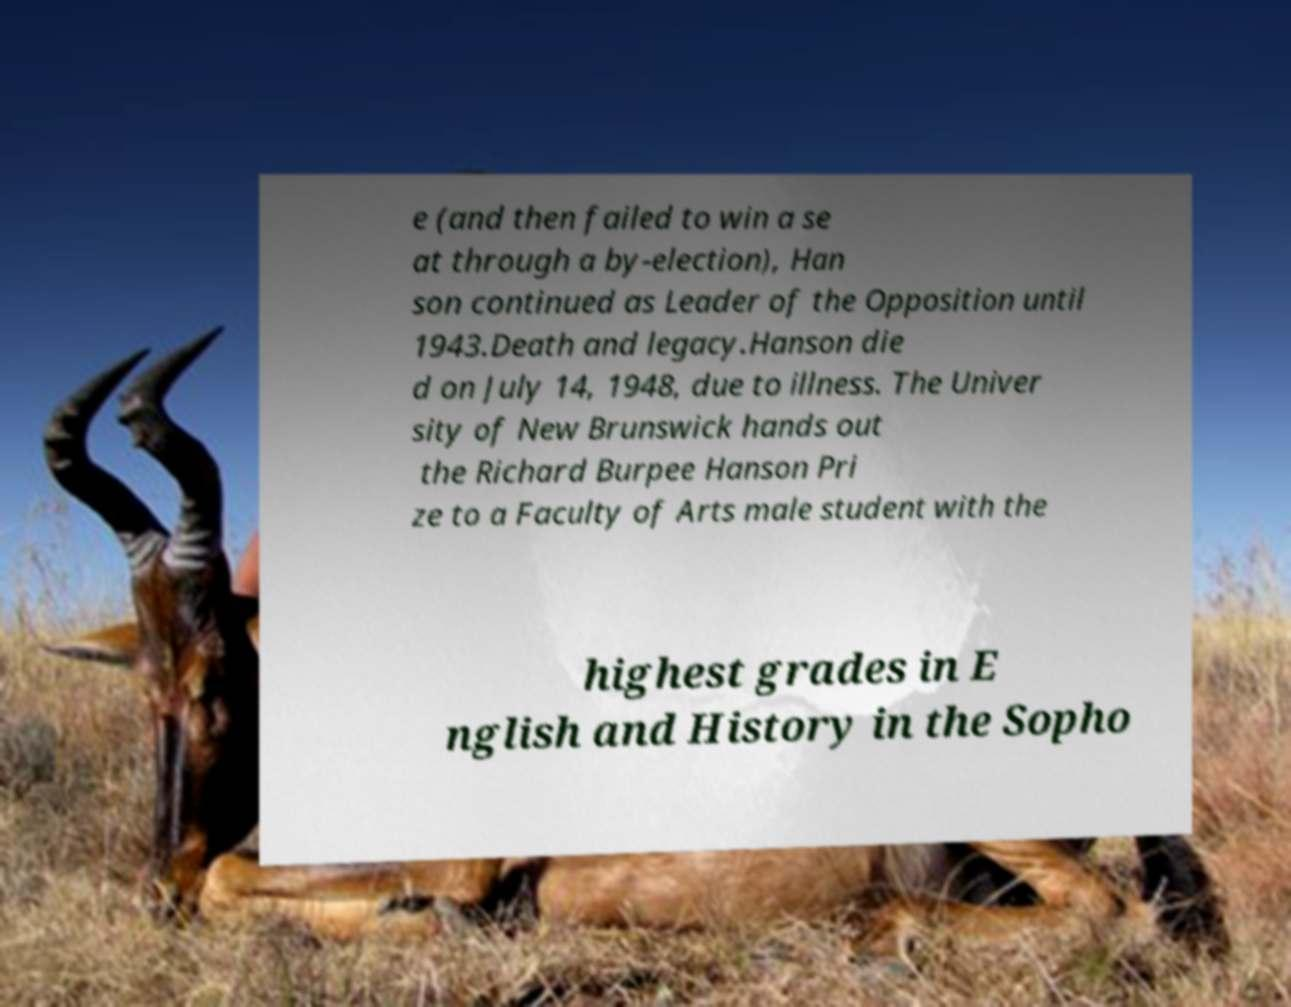Could you assist in decoding the text presented in this image and type it out clearly? e (and then failed to win a se at through a by-election), Han son continued as Leader of the Opposition until 1943.Death and legacy.Hanson die d on July 14, 1948, due to illness. The Univer sity of New Brunswick hands out the Richard Burpee Hanson Pri ze to a Faculty of Arts male student with the highest grades in E nglish and History in the Sopho 